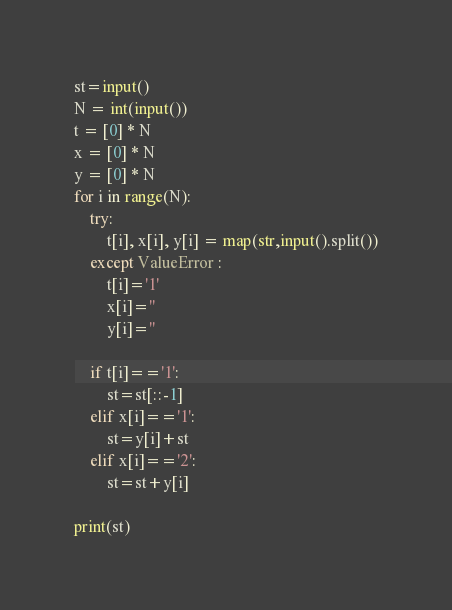Convert code to text. <code><loc_0><loc_0><loc_500><loc_500><_Python_>st=input()
N = int(input())
t = [0] * N
x = [0] * N
y = [0] * N
for i in range(N):
    try:
        t[i], x[i], y[i] = map(str,input().split())
    except ValueError :
        t[i]='1'
        x[i]=''
        y[i]=''

    if t[i]=='1':
        st=st[::-1]
    elif x[i]=='1':
        st=y[i]+st
    elif x[i]=='2':
        st=st+y[i]

print(st)</code> 